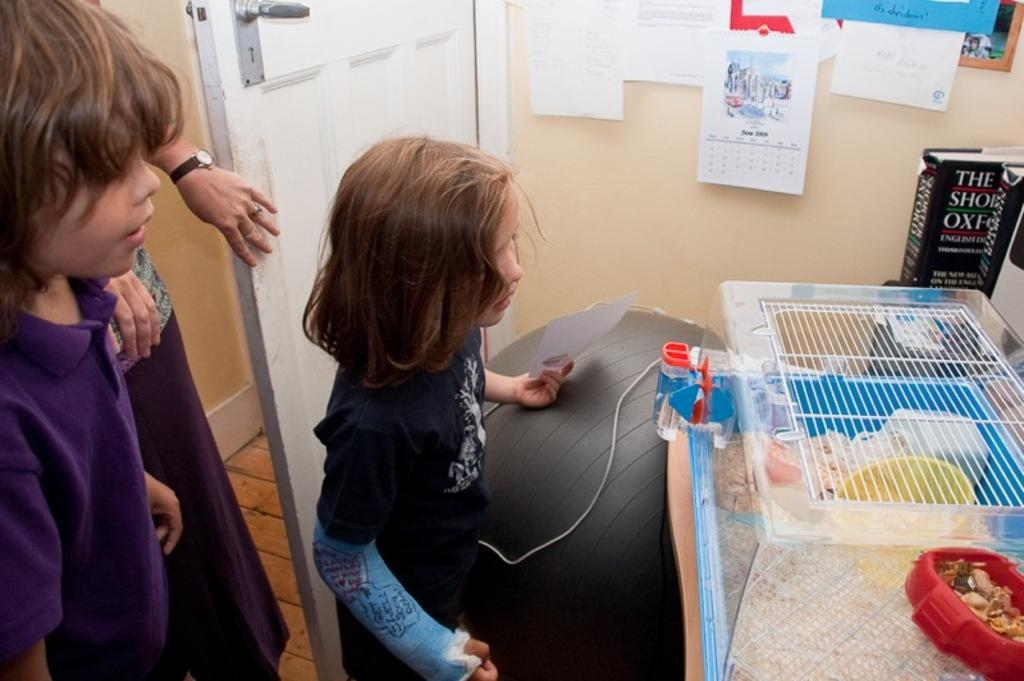Provide a one-sentence caption for the provided image. two children looking at a hamster cage in the month of june. 